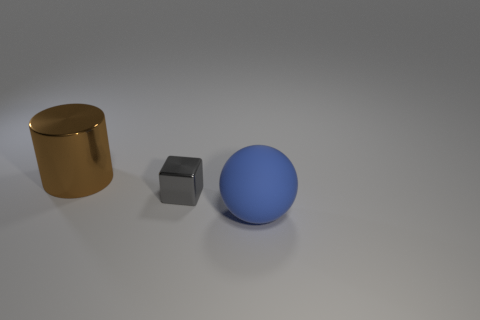What number of blue rubber balls are on the right side of the big thing that is right of the big thing on the left side of the big rubber object?
Your answer should be very brief. 0. Are there more tiny metal blocks than objects?
Your answer should be very brief. No. Do the brown thing and the ball have the same size?
Offer a very short reply. Yes. How many objects are metal objects or large yellow metallic cubes?
Make the answer very short. 2. What shape is the large thing in front of the metal thing on the left side of the metallic thing in front of the brown cylinder?
Your answer should be very brief. Sphere. Are there any other things that have the same size as the gray metallic block?
Keep it short and to the point. No. Is the shape of the shiny object on the left side of the tiny gray metal object the same as the big thing right of the large cylinder?
Provide a succinct answer. No. Are there fewer rubber objects that are on the left side of the big cylinder than tiny metal objects on the left side of the big sphere?
Offer a terse response. Yes. How many other objects are the same shape as the large matte thing?
Your response must be concise. 0. What shape is the other large thing that is made of the same material as the gray thing?
Offer a very short reply. Cylinder. 